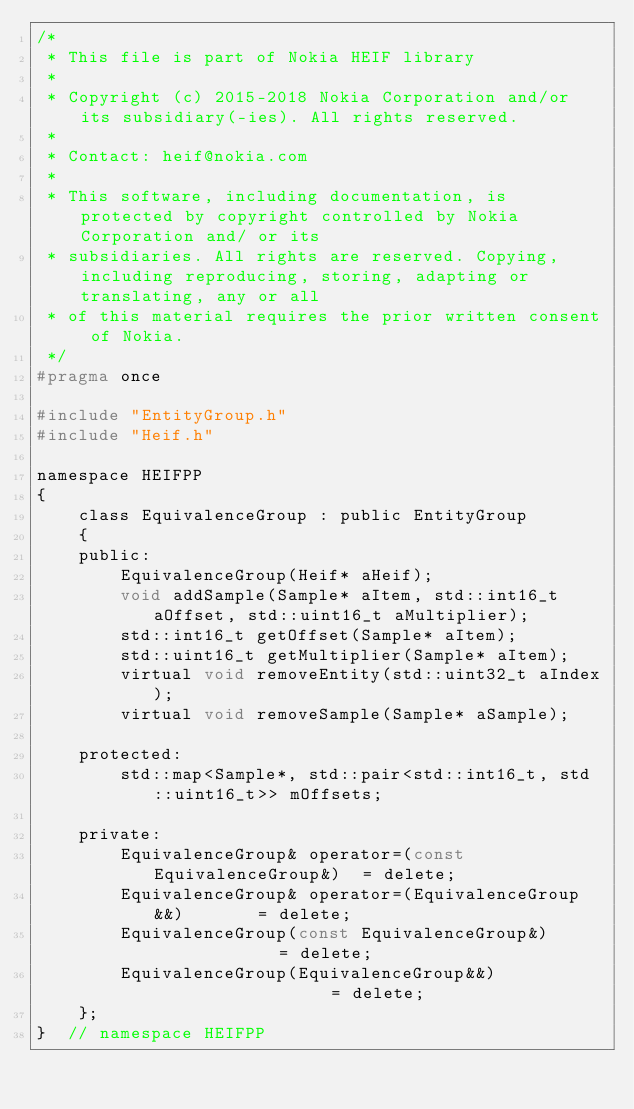<code> <loc_0><loc_0><loc_500><loc_500><_C_>/*
 * This file is part of Nokia HEIF library
 *
 * Copyright (c) 2015-2018 Nokia Corporation and/or its subsidiary(-ies). All rights reserved.
 *
 * Contact: heif@nokia.com
 *
 * This software, including documentation, is protected by copyright controlled by Nokia Corporation and/ or its
 * subsidiaries. All rights are reserved. Copying, including reproducing, storing, adapting or translating, any or all
 * of this material requires the prior written consent of Nokia.
 */
#pragma once

#include "EntityGroup.h"
#include "Heif.h"

namespace HEIFPP
{
    class EquivalenceGroup : public EntityGroup
    {
    public:
        EquivalenceGroup(Heif* aHeif);
        void addSample(Sample* aItem, std::int16_t aOffset, std::uint16_t aMultiplier);
        std::int16_t getOffset(Sample* aItem);
        std::uint16_t getMultiplier(Sample* aItem);
        virtual void removeEntity(std::uint32_t aIndex);
        virtual void removeSample(Sample* aSample);

    protected:
        std::map<Sample*, std::pair<std::int16_t, std::uint16_t>> mOffsets;

    private:
        EquivalenceGroup& operator=(const EquivalenceGroup&)  = delete;
        EquivalenceGroup& operator=(EquivalenceGroup&&)       = delete;
        EquivalenceGroup(const EquivalenceGroup&)             = delete;
        EquivalenceGroup(EquivalenceGroup&&)                  = delete;
    };
}  // namespace HEIFPP</code> 